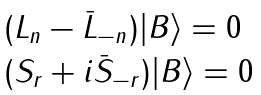Convert formula to latex. <formula><loc_0><loc_0><loc_500><loc_500>\begin{array} { l } ( L _ { n } - \bar { L } _ { - n } ) | B \rangle = 0 \\ ( S _ { r } + i \bar { S } _ { - r } ) | B \rangle = 0 \end{array}</formula> 